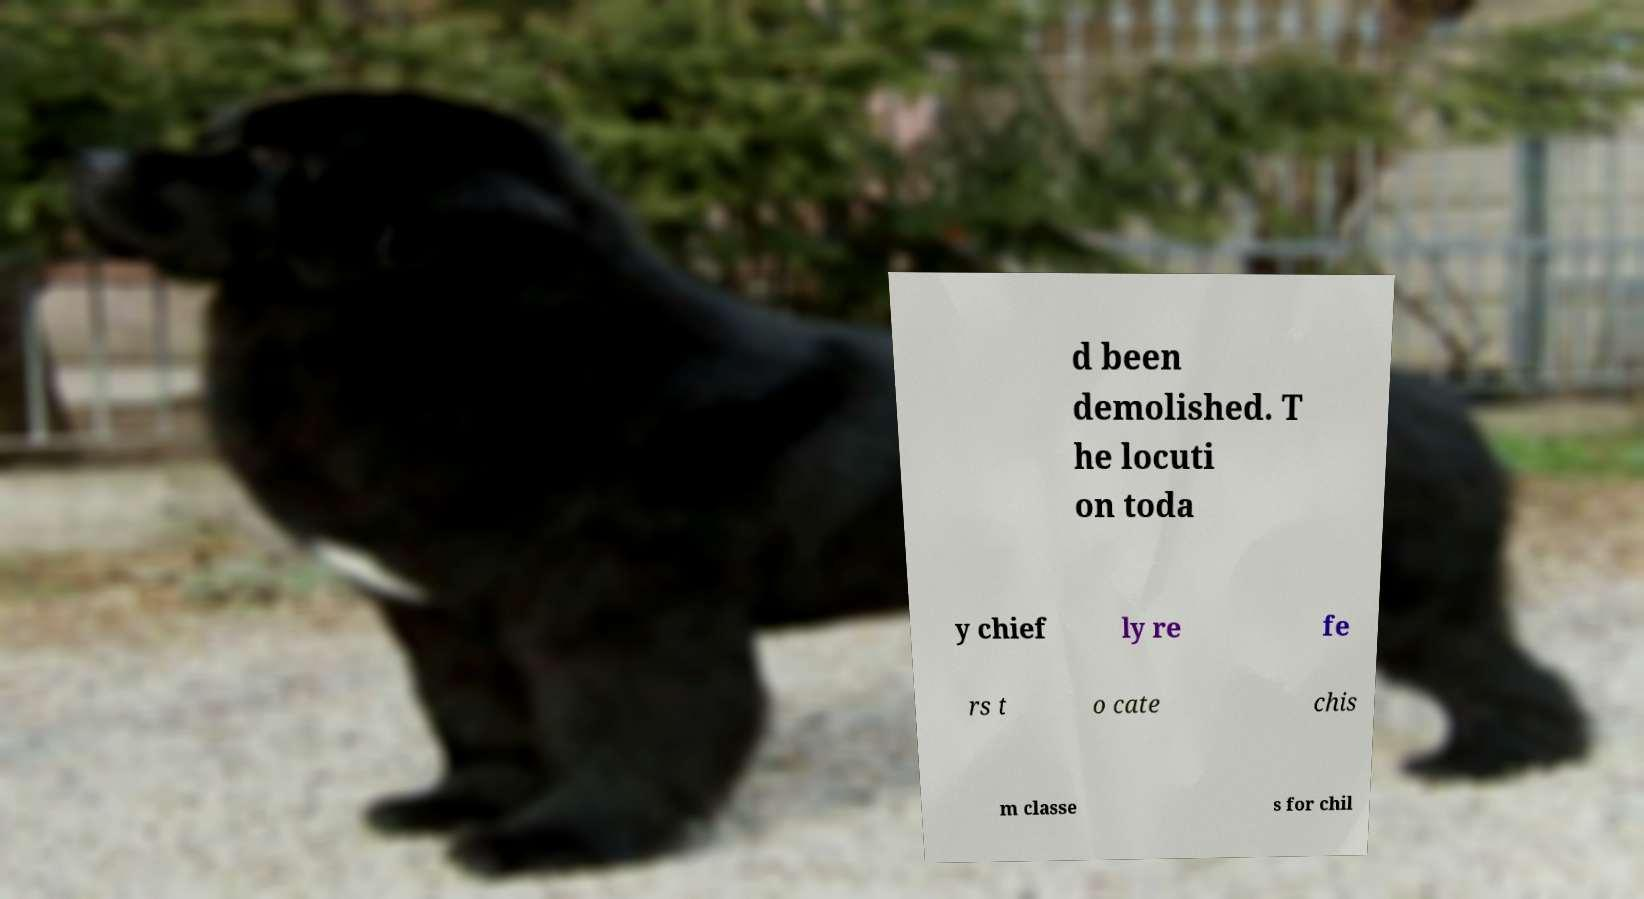Can you read and provide the text displayed in the image?This photo seems to have some interesting text. Can you extract and type it out for me? d been demolished. T he locuti on toda y chief ly re fe rs t o cate chis m classe s for chil 